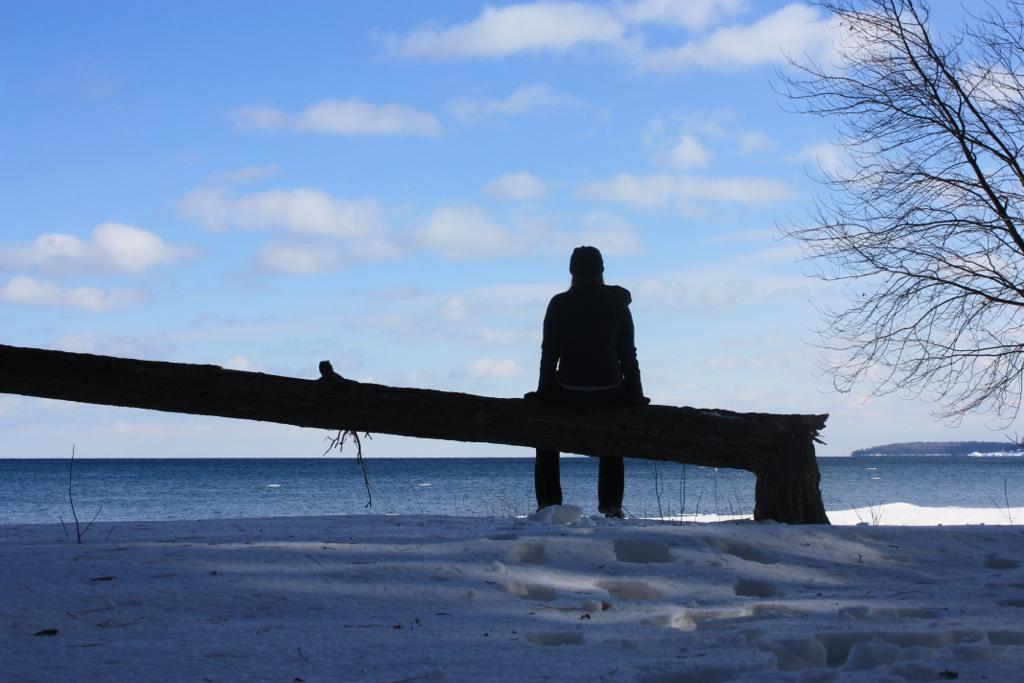What is the person in the image doing? The person is sitting on a wooden pole in the image. What is the ground made of in the image? Snow is visible at the bottom of the image. What can be seen in the background of the image? The sky is visible in the background of the image. What type of vegetation is present in the image? There are plants in the image. How many fangs does the tiger have in the image? There is no tiger present in the image, so it is not possible to determine the number of fangs. 